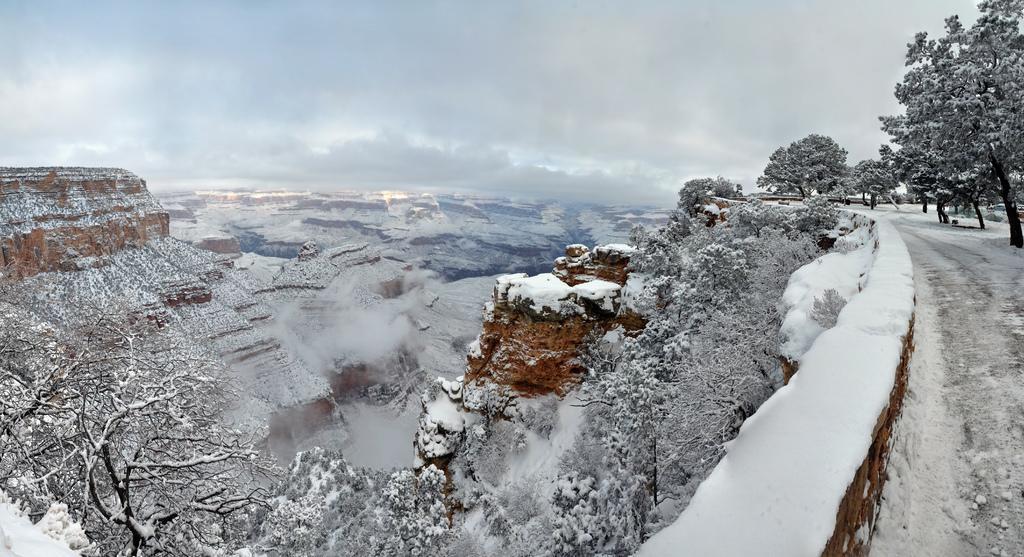Please provide a concise description of this image. In this image we can see some hills and the trees which are covered with the snow. On the right side we can see a fence. On the backside we can see the sky which looks cloudy. 